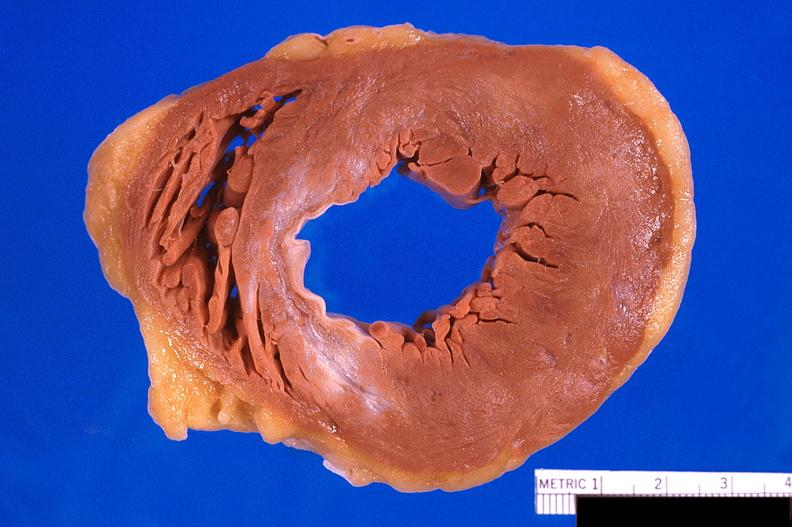does this image show heart, old myocardial infarction with fibrosis?
Answer the question using a single word or phrase. Yes 